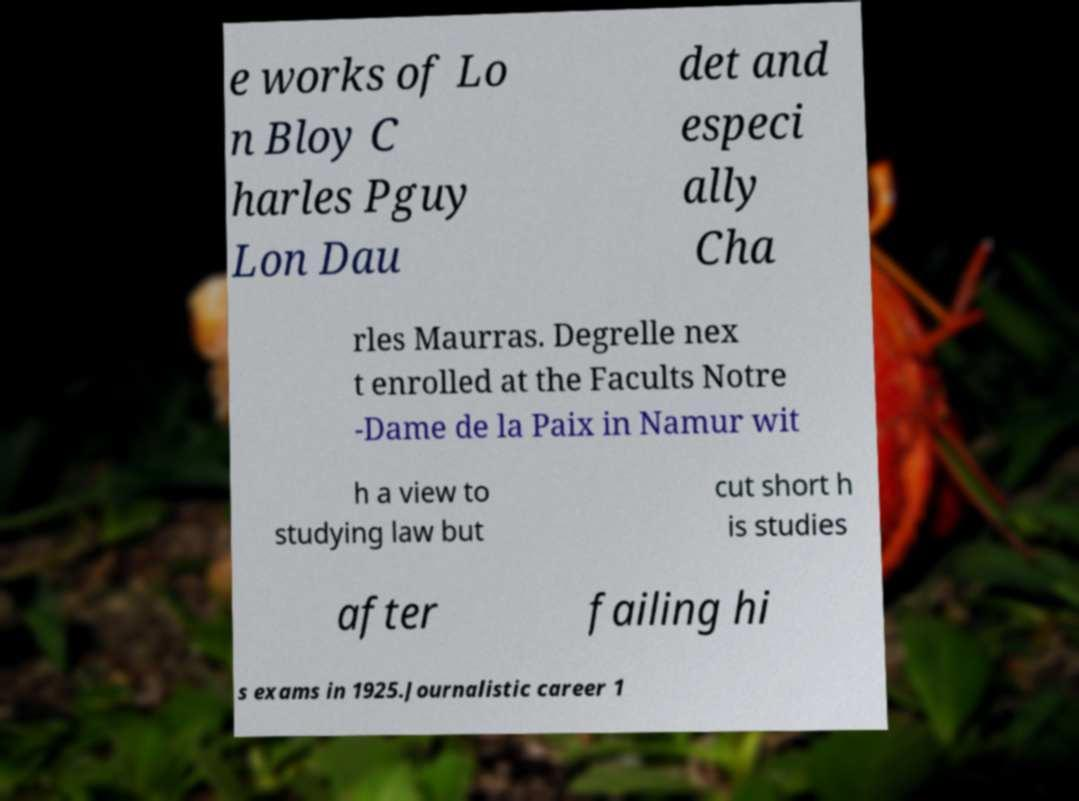For documentation purposes, I need the text within this image transcribed. Could you provide that? e works of Lo n Bloy C harles Pguy Lon Dau det and especi ally Cha rles Maurras. Degrelle nex t enrolled at the Facults Notre -Dame de la Paix in Namur wit h a view to studying law but cut short h is studies after failing hi s exams in 1925.Journalistic career 1 